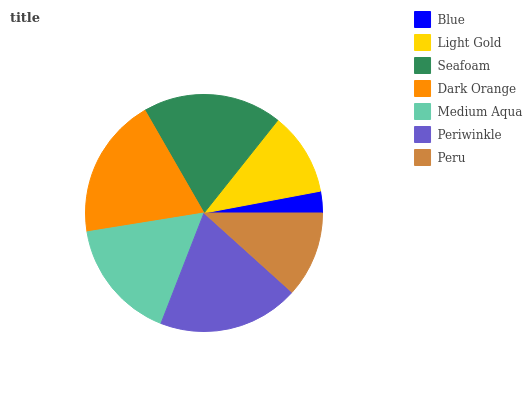Is Blue the minimum?
Answer yes or no. Yes. Is Dark Orange the maximum?
Answer yes or no. Yes. Is Light Gold the minimum?
Answer yes or no. No. Is Light Gold the maximum?
Answer yes or no. No. Is Light Gold greater than Blue?
Answer yes or no. Yes. Is Blue less than Light Gold?
Answer yes or no. Yes. Is Blue greater than Light Gold?
Answer yes or no. No. Is Light Gold less than Blue?
Answer yes or no. No. Is Medium Aqua the high median?
Answer yes or no. Yes. Is Medium Aqua the low median?
Answer yes or no. Yes. Is Blue the high median?
Answer yes or no. No. Is Light Gold the low median?
Answer yes or no. No. 